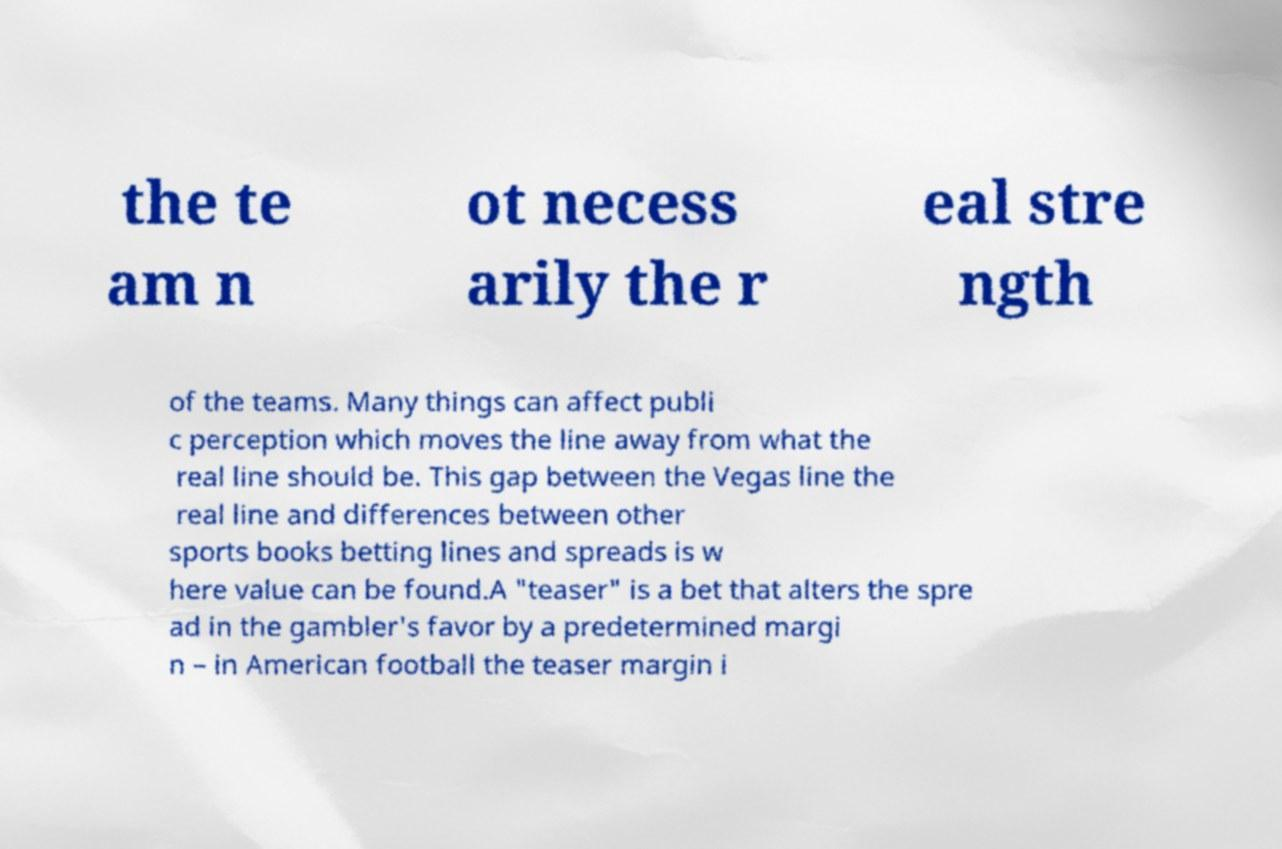Can you read and provide the text displayed in the image?This photo seems to have some interesting text. Can you extract and type it out for me? the te am n ot necess arily the r eal stre ngth of the teams. Many things can affect publi c perception which moves the line away from what the real line should be. This gap between the Vegas line the real line and differences between other sports books betting lines and spreads is w here value can be found.A "teaser" is a bet that alters the spre ad in the gambler's favor by a predetermined margi n – in American football the teaser margin i 